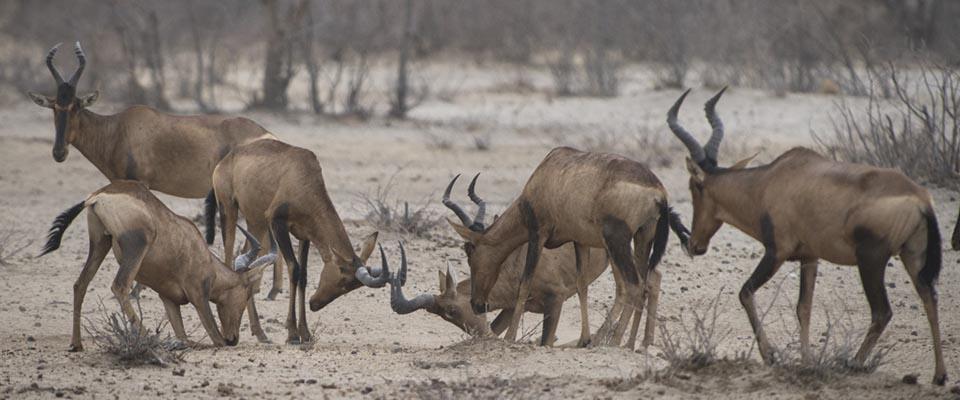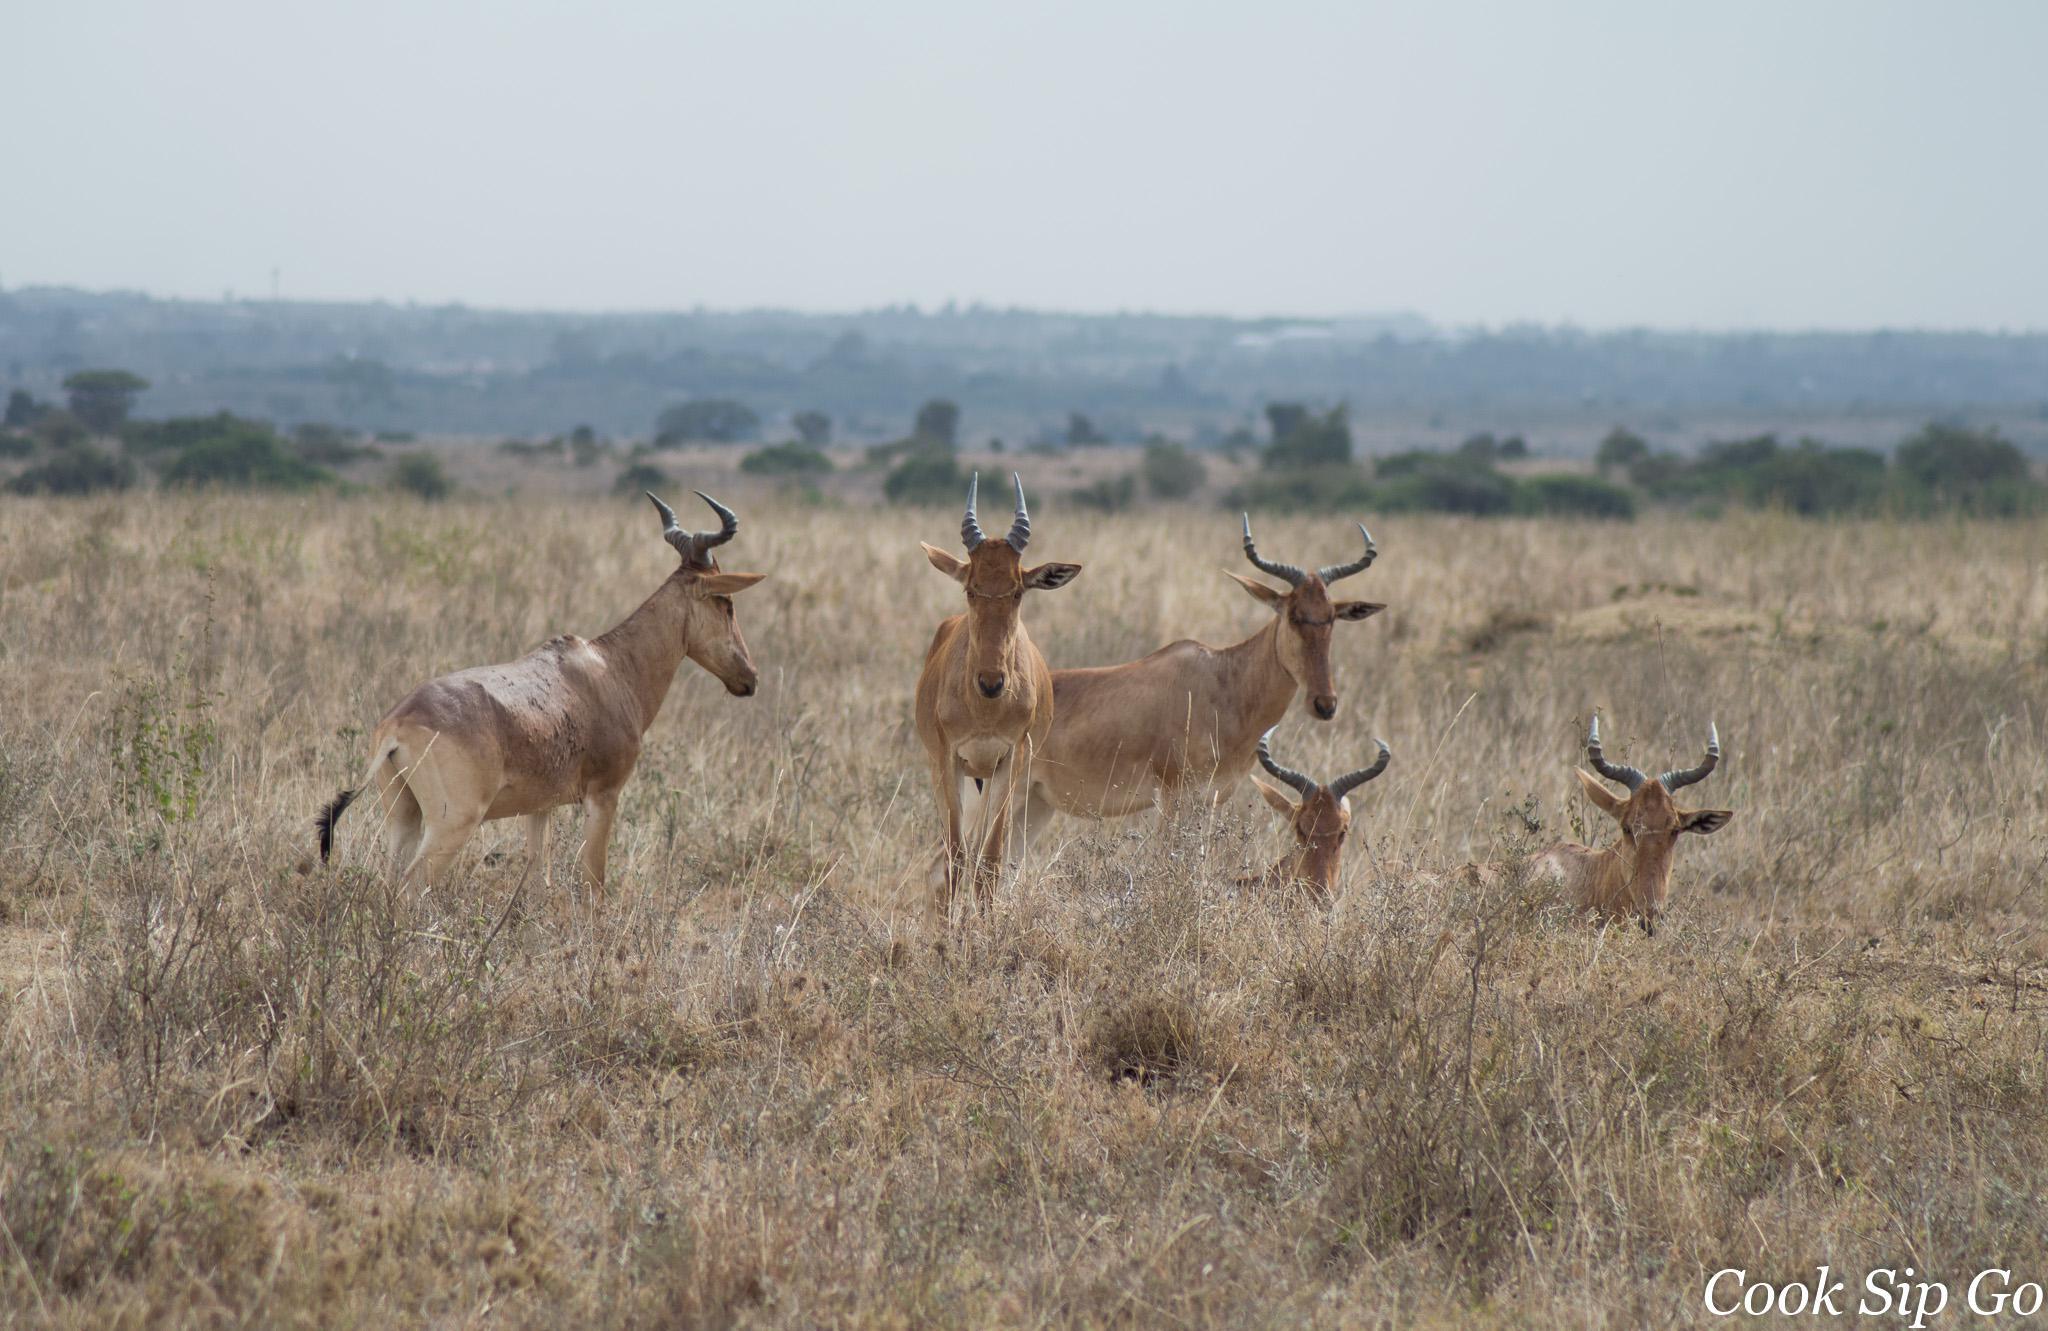The first image is the image on the left, the second image is the image on the right. Assess this claim about the two images: "There are at least four animals in the image on the right.". Correct or not? Answer yes or no. Yes. 